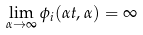Convert formula to latex. <formula><loc_0><loc_0><loc_500><loc_500>\lim _ { \alpha \to \infty } \phi _ { i } ( \alpha t , \alpha ) = \infty</formula> 